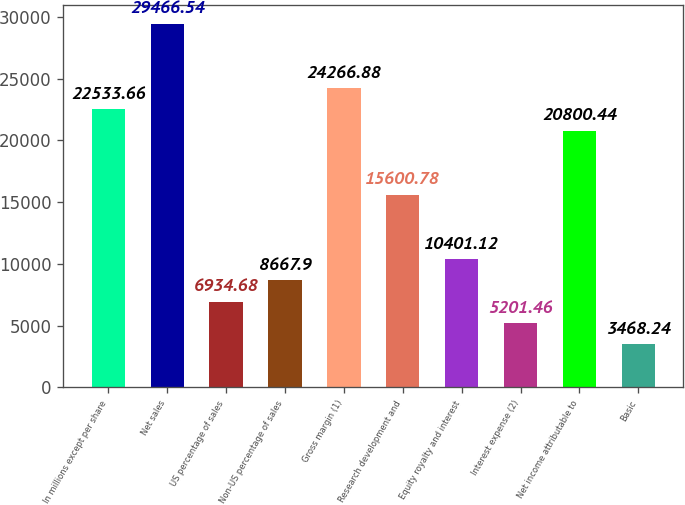Convert chart. <chart><loc_0><loc_0><loc_500><loc_500><bar_chart><fcel>In millions except per share<fcel>Net sales<fcel>US percentage of sales<fcel>Non-US percentage of sales<fcel>Gross margin (1)<fcel>Research development and<fcel>Equity royalty and interest<fcel>Interest expense (2)<fcel>Net income attributable to<fcel>Basic<nl><fcel>22533.7<fcel>29466.5<fcel>6934.68<fcel>8667.9<fcel>24266.9<fcel>15600.8<fcel>10401.1<fcel>5201.46<fcel>20800.4<fcel>3468.24<nl></chart> 